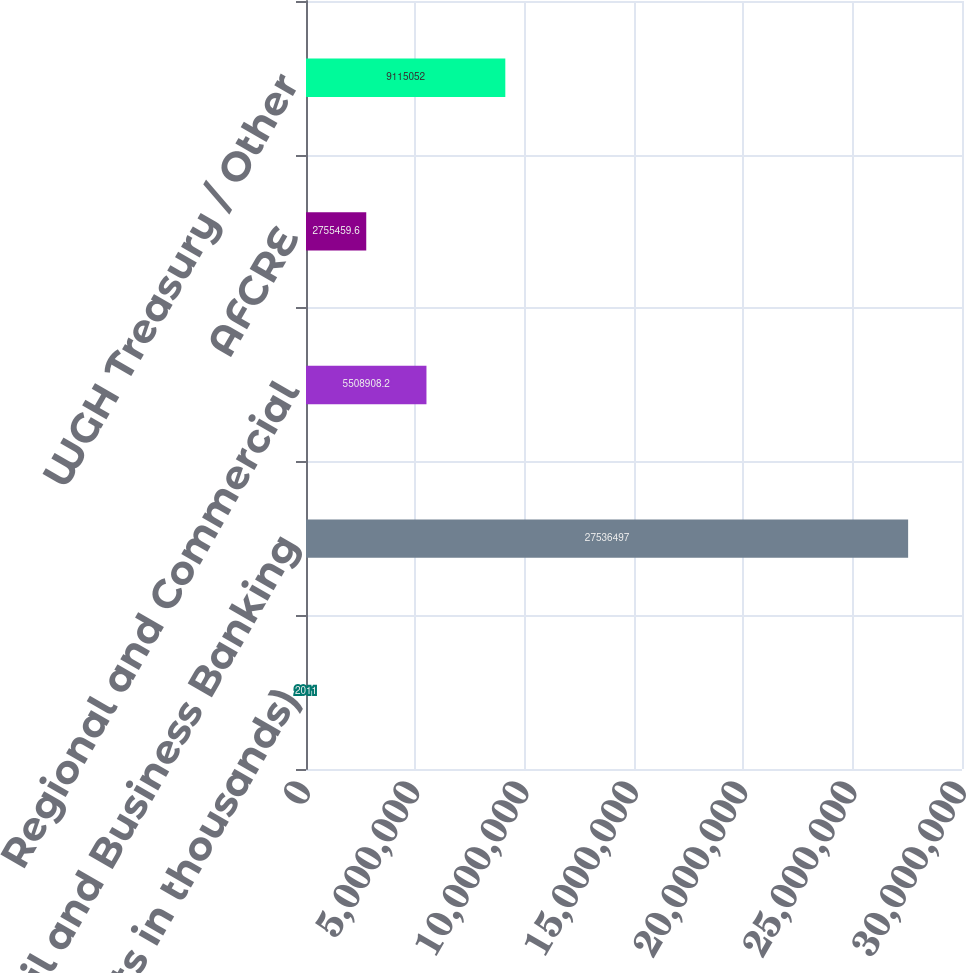<chart> <loc_0><loc_0><loc_500><loc_500><bar_chart><fcel>(dollar amounts in thousands)<fcel>Retail and Business Banking<fcel>Regional and Commercial<fcel>AFCRE<fcel>WGH Treasury / Other<nl><fcel>2011<fcel>2.75365e+07<fcel>5.50891e+06<fcel>2.75546e+06<fcel>9.11505e+06<nl></chart> 